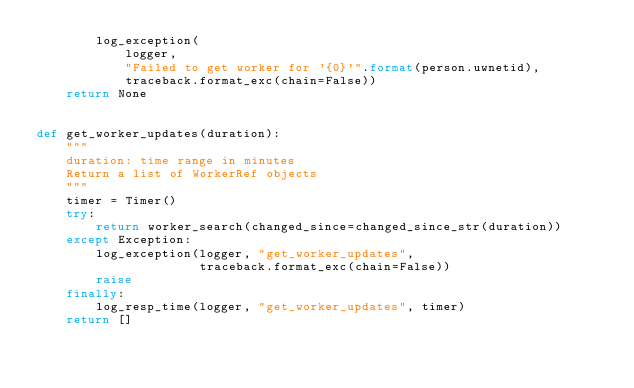<code> <loc_0><loc_0><loc_500><loc_500><_Python_>        log_exception(
            logger,
            "Failed to get worker for '{0}'".format(person.uwnetid),
            traceback.format_exc(chain=False))
    return None


def get_worker_updates(duration):
    """
    duration: time range in minutes
    Return a list of WorkerRef objects
    """
    timer = Timer()
    try:
        return worker_search(changed_since=changed_since_str(duration))
    except Exception:
        log_exception(logger, "get_worker_updates",
                      traceback.format_exc(chain=False))
        raise
    finally:
        log_resp_time(logger, "get_worker_updates", timer)
    return []
</code> 